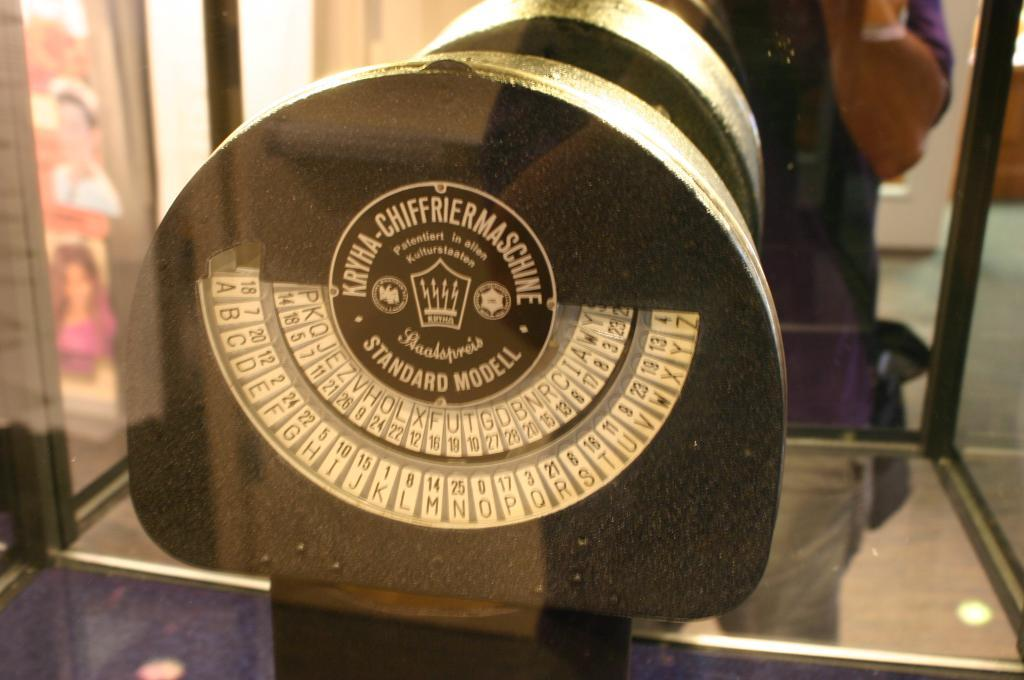What can be seen in the image? There is an object in the image. What is written or printed on the object? There is text on the object. Is there anyone else in the image besides the object? Yes, there is a person standing in front of the object. Can you tell me how many times the person touched the object in the image? There is no information about the person touching the object in the image, so we cannot determine how many times they touched it. 